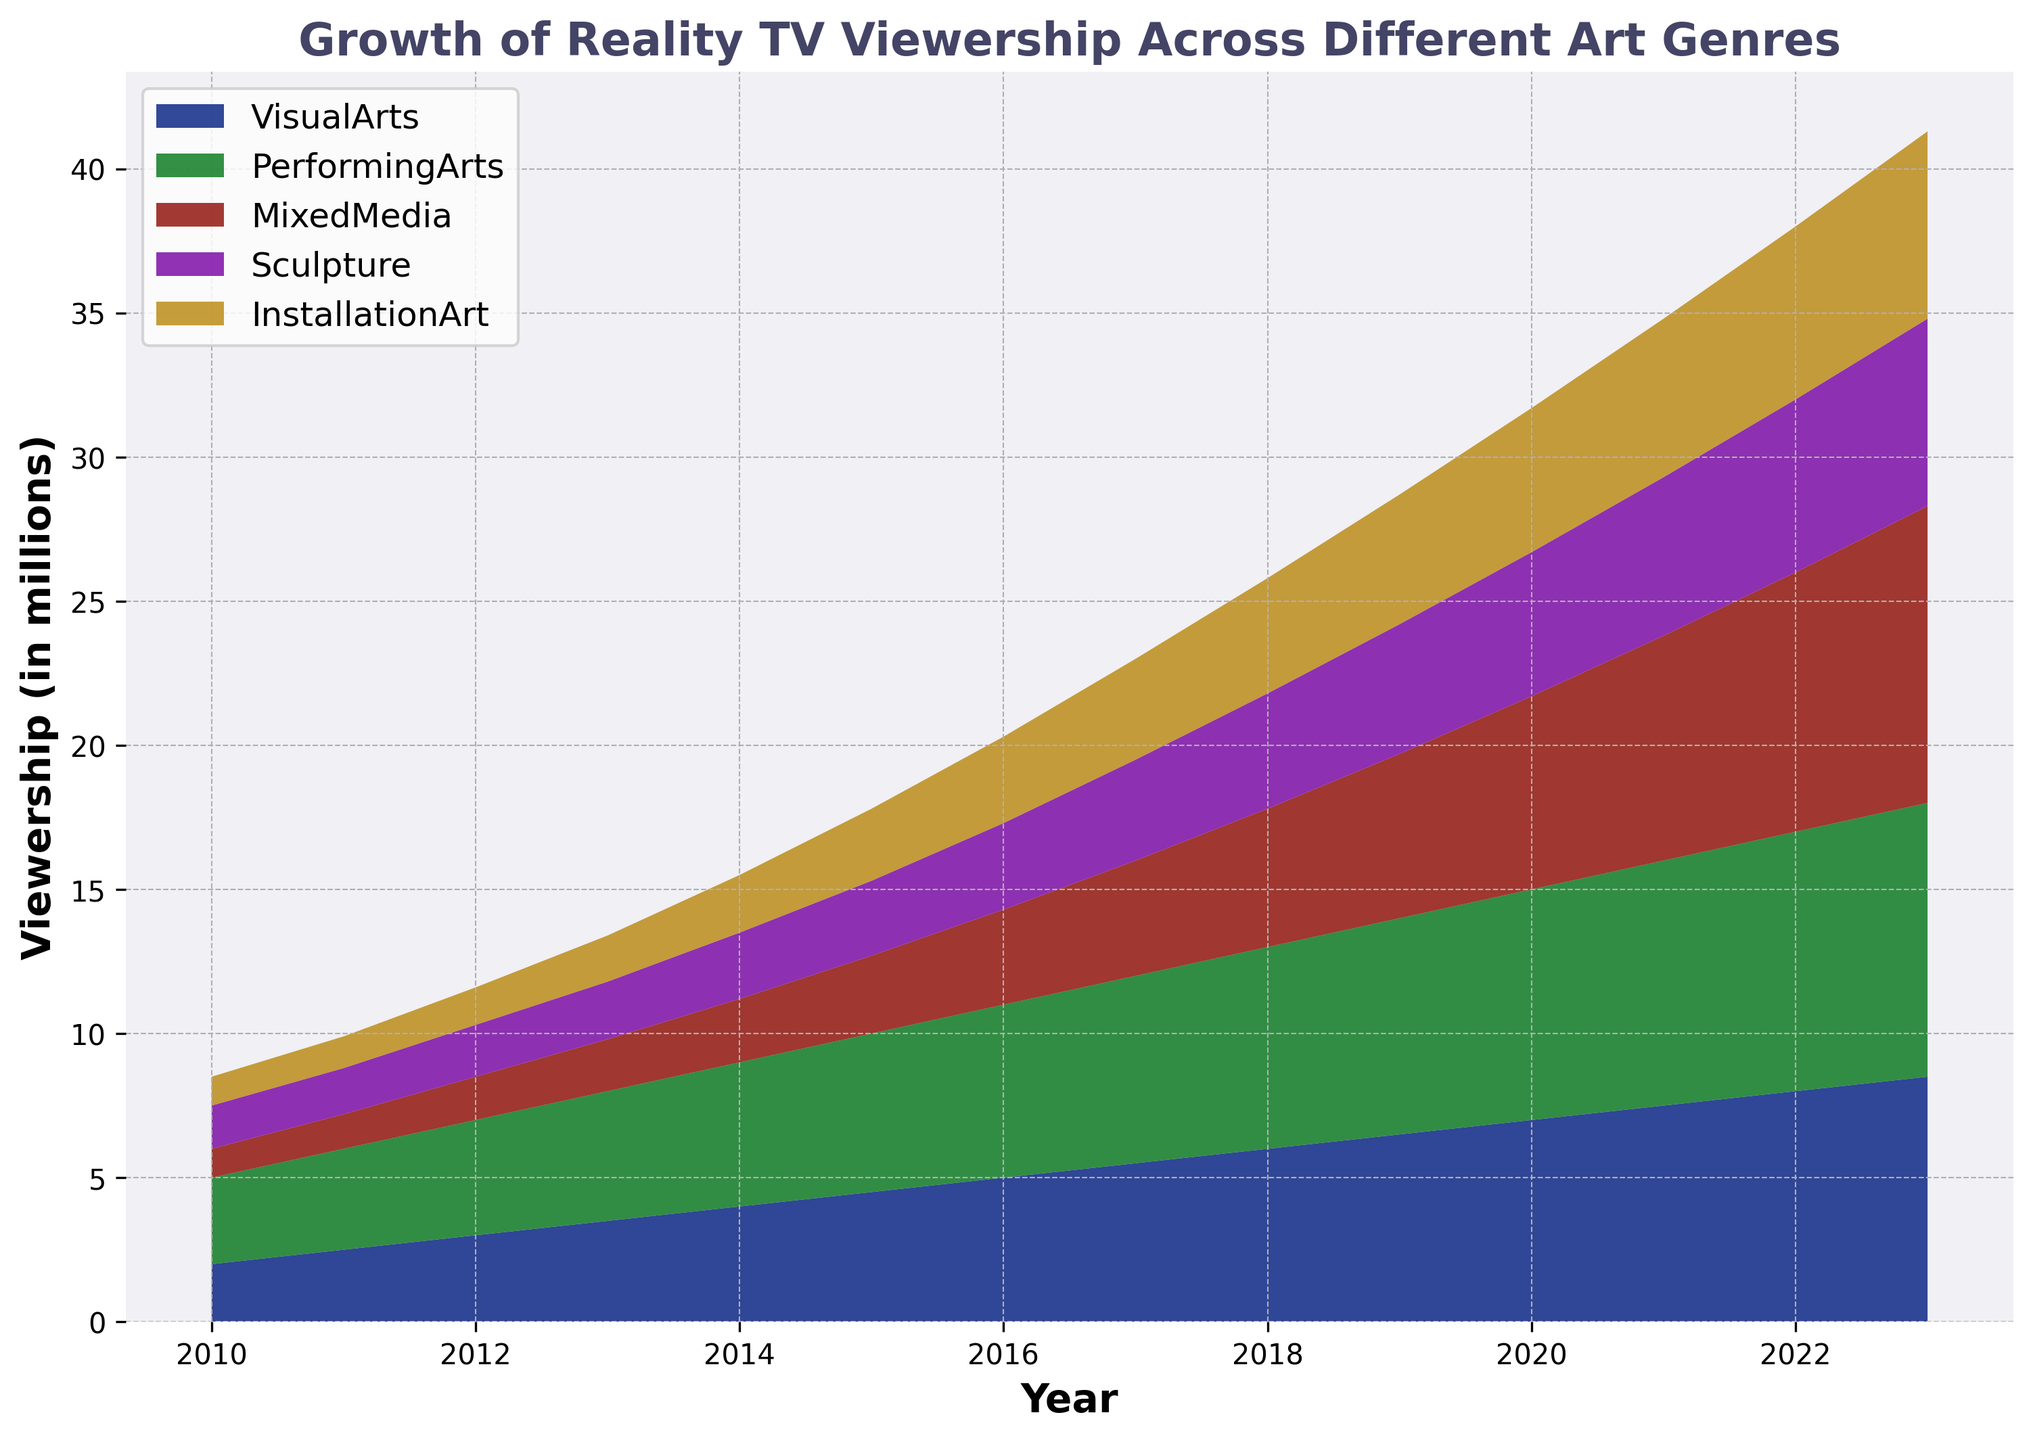What is the overall trend of Reality TV viewership in Visual Arts from 2010 to 2023? Visual Arts viewership shows a consistent upward trend from 2 million in 2010 to 8.5 million in 2023.
Answer: Consistent upward trend Which year had the highest growth rate in Mixed Media viewership? By examining the chart, note that the steepest increase in Mixed Media viewership occurs between 2021 (7.8 million) and 2022 (9 million).
Answer: 2022 Compare the growth of Performing Arts and Installation Art from 2015 to 2020. Which one grew more? Performing Arts grew from 5.5 million in 2015 to 8 million in 2020, an increase of 2.5 million. Installation Art grew from 2.5 million in 2015 to 5 million in 2020, an increase of 2.5 million. Hence, both genres grew by the same amount.
Answer: Both genres grew the same What is the total viewership in 2023 for all the genres combined? Add the viewership of all genres in 2023: Visual Arts (8.5) + Performing Arts (9.5) + Mixed Media (10.3) + Sculpture (6.5) + Installation Art (6.5) = 41.3 million.
Answer: 41.3 million In what year did Sculpture viewership first reach 3 million? Sculpture viewership first reached 3 million in 2016.
Answer: 2016 Which genre had the highest viewership in 2019? By visually analyzing the heights of the areas in 2019, Performing Arts had the highest viewership at 7.5 million.
Answer: Performing Arts What is the incremental growth in Visual Arts viewership from 2010 to 2023? The viewership increased from 2 million in 2010 to 8.5 million in 2023, leading to an incremental growth of 6.5 million.
Answer: 6.5 million Compare the total viewership of Mixed Media and Sculpture in 2020. Which one had more viewers, and by how much? In 2020, Mixed Media had 6.7 million viewers, and Sculpture had 5 million. The difference is 6.7 - 5 = 1.7 million.
Answer: Mixed Media by 1.7 million How does the viewership trend for Installation Art from 2015 to 2023 compare to that of Performing Arts? Installation Art viewership shows steady growth from 2.5 to 6.5 million in this period. Performing Arts viewership grew from 5.5 to 9.5 million, indicating more viewers but not as consistent a rate.
Answer: Installation Art showed steadier growth Which genre experienced the smallest change in viewership between 2022 and 2023? The viewership for Sculpture and Installation Art remained the same from 2022 to 2023 at 6.5 million each.
Answer: Sculpture and Installation Art 